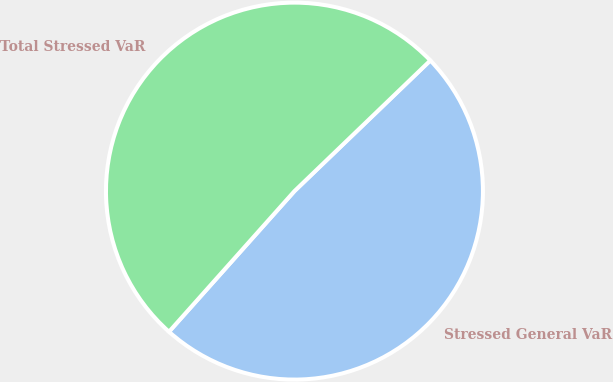<chart> <loc_0><loc_0><loc_500><loc_500><pie_chart><fcel>Stressed General VaR<fcel>Total Stressed VaR<nl><fcel>48.78%<fcel>51.22%<nl></chart> 